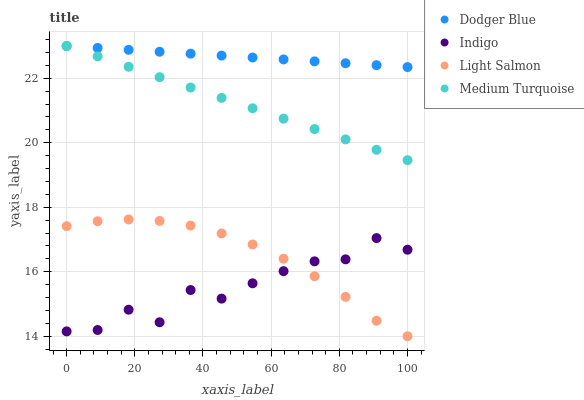Does Indigo have the minimum area under the curve?
Answer yes or no. Yes. Does Dodger Blue have the maximum area under the curve?
Answer yes or no. Yes. Does Light Salmon have the minimum area under the curve?
Answer yes or no. No. Does Light Salmon have the maximum area under the curve?
Answer yes or no. No. Is Dodger Blue the smoothest?
Answer yes or no. Yes. Is Indigo the roughest?
Answer yes or no. Yes. Is Light Salmon the smoothest?
Answer yes or no. No. Is Light Salmon the roughest?
Answer yes or no. No. Does Light Salmon have the lowest value?
Answer yes or no. Yes. Does Dodger Blue have the lowest value?
Answer yes or no. No. Does Medium Turquoise have the highest value?
Answer yes or no. Yes. Does Light Salmon have the highest value?
Answer yes or no. No. Is Light Salmon less than Dodger Blue?
Answer yes or no. Yes. Is Dodger Blue greater than Light Salmon?
Answer yes or no. Yes. Does Dodger Blue intersect Medium Turquoise?
Answer yes or no. Yes. Is Dodger Blue less than Medium Turquoise?
Answer yes or no. No. Is Dodger Blue greater than Medium Turquoise?
Answer yes or no. No. Does Light Salmon intersect Dodger Blue?
Answer yes or no. No. 